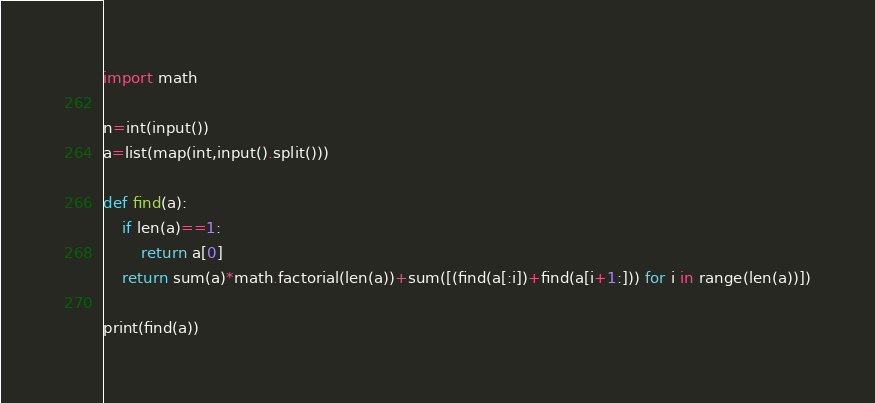Convert code to text. <code><loc_0><loc_0><loc_500><loc_500><_Python_>import math

n=int(input())
a=list(map(int,input().split()))

def find(a):
    if len(a)==1:
        return a[0]
    return sum(a)*math.factorial(len(a))+sum([(find(a[:i])+find(a[i+1:])) for i in range(len(a))])
  
print(find(a))
</code> 